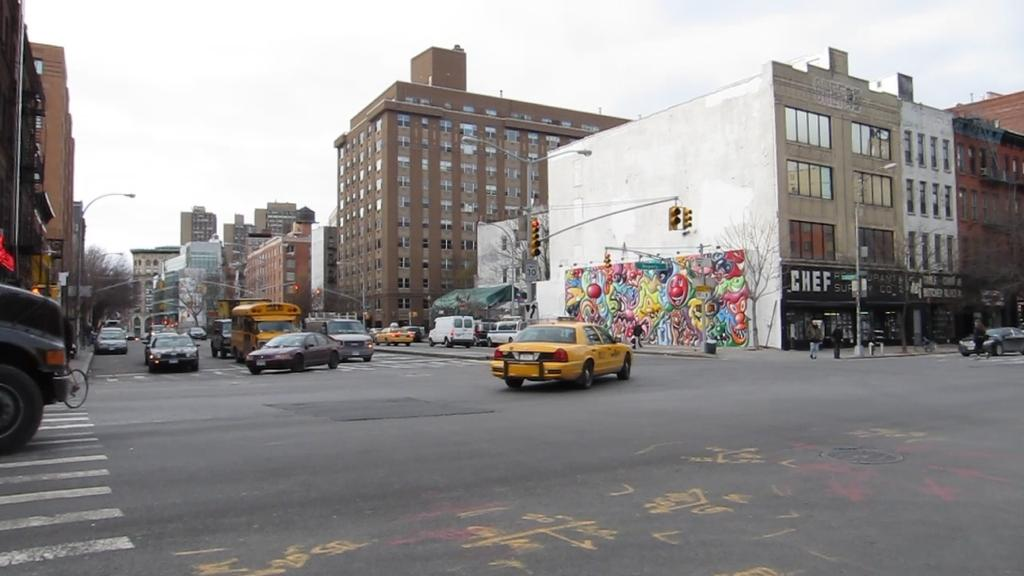<image>
Relay a brief, clear account of the picture shown. A busy intersection has a taxi in it and a storefront that says Chef. 